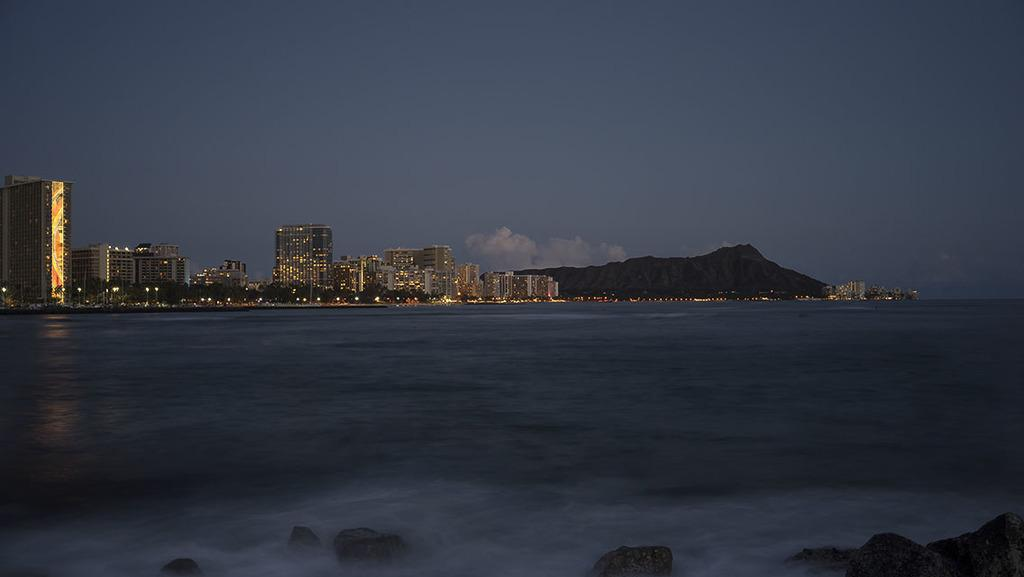What type of natural feature can be seen in the image? There is a sea in the image. What man-made structures are present in the image? There are buildings in the image. What type of illumination can be seen in the image? There are lights in the image. What type of vegetation is present in the image? There are trees in the image. What type of terrain is present in the image? There are stones in the image. What type of geological feature is present in the image? There are mountains in the image. What is visible in the background of the image? The sky is visible in the background of the image. What type of weather can be inferred from the image? Clouds are present in the sky, suggesting that it might be a partly cloudy day. Where is the garden located in the image? There is no garden present in the image. What type of bird can be seen interacting with the lights in the image? There are no birds present in the image. 